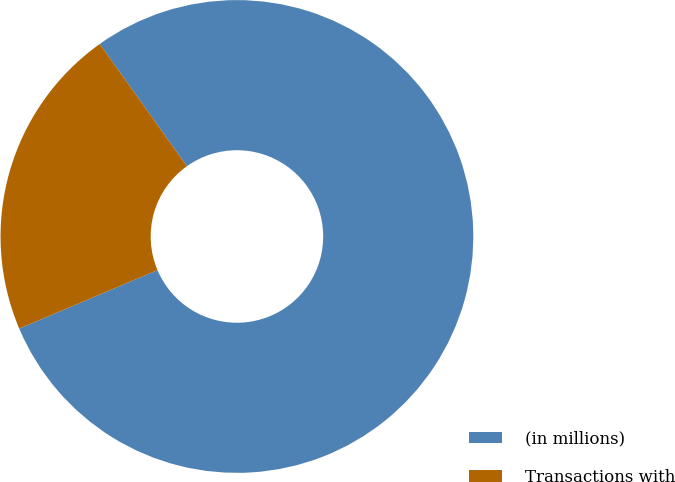<chart> <loc_0><loc_0><loc_500><loc_500><pie_chart><fcel>(in millions)<fcel>Transactions with<nl><fcel>78.48%<fcel>21.52%<nl></chart> 